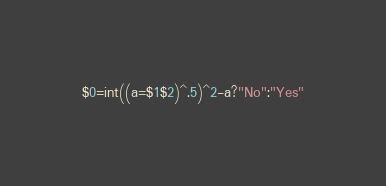Convert code to text. <code><loc_0><loc_0><loc_500><loc_500><_Awk_>$0=int((a=$1$2)^.5)^2-a?"No":"Yes"</code> 